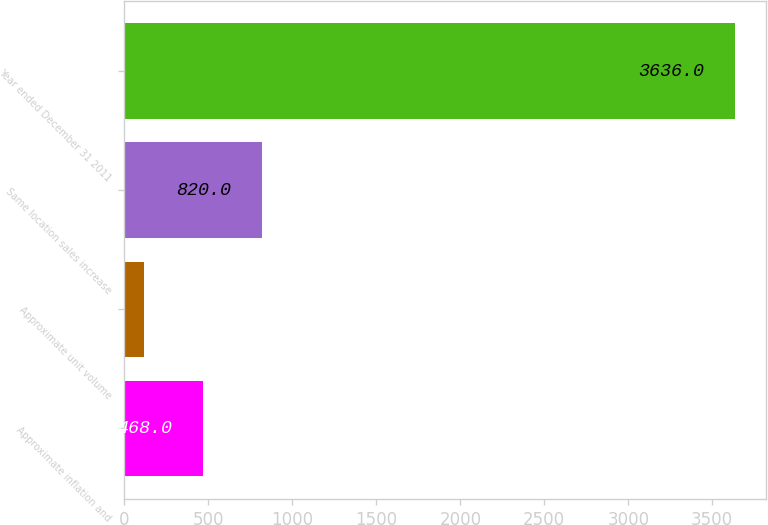Convert chart to OTSL. <chart><loc_0><loc_0><loc_500><loc_500><bar_chart><fcel>Approximate inflation and<fcel>Approximate unit volume<fcel>Same location sales increase<fcel>Year ended December 31 2011<nl><fcel>468<fcel>116<fcel>820<fcel>3636<nl></chart> 